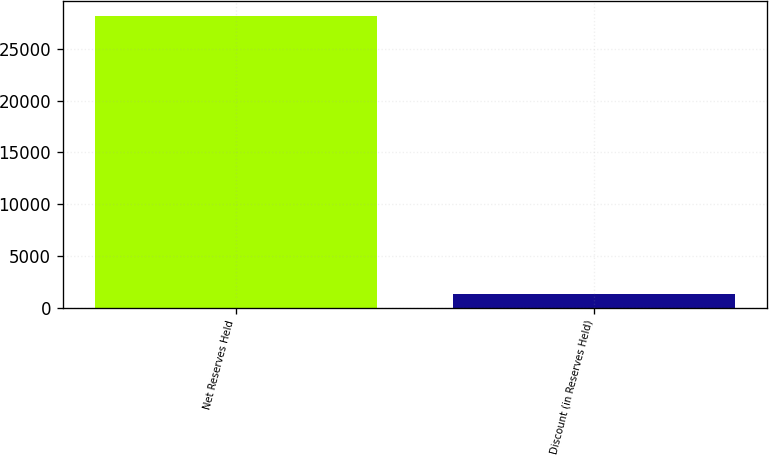Convert chart. <chart><loc_0><loc_0><loc_500><loc_500><bar_chart><fcel>Net Reserves Held<fcel>Discount (in Reserves Held)<nl><fcel>28252.4<fcel>1287<nl></chart> 